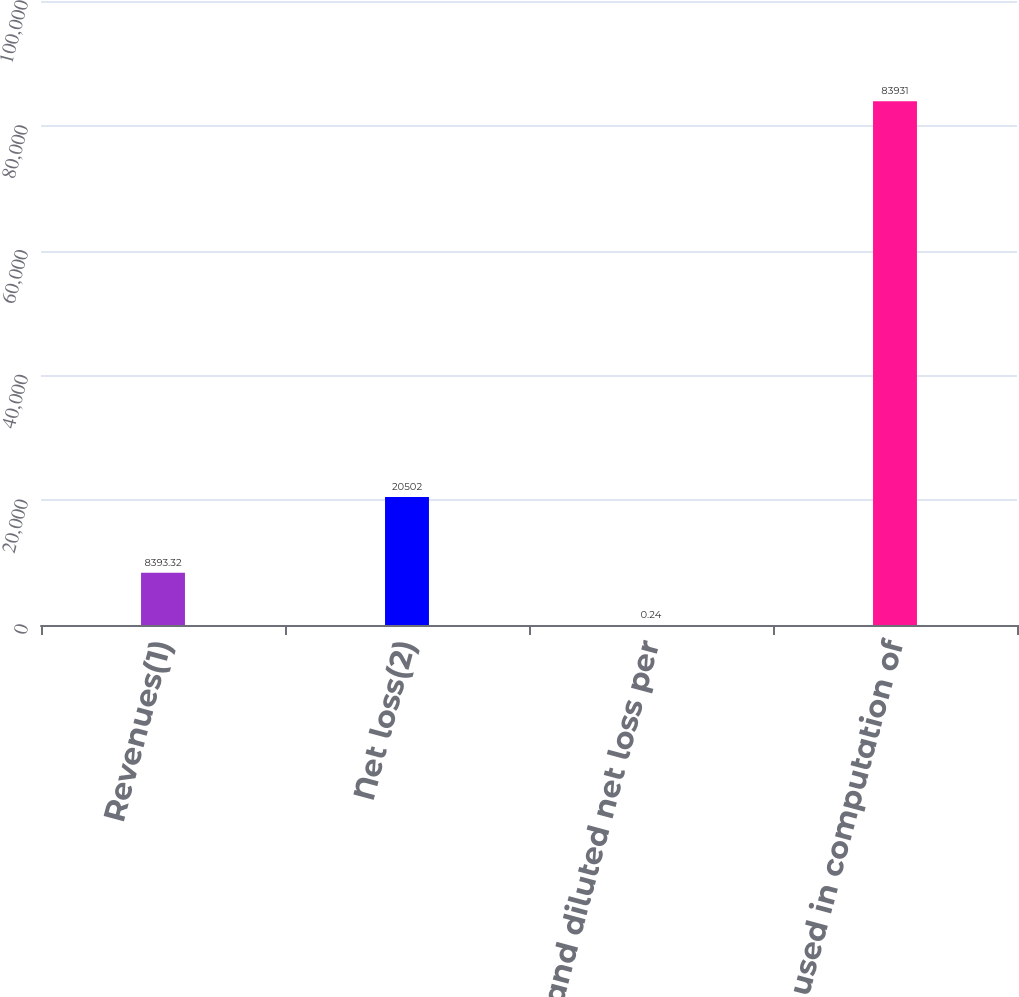Convert chart. <chart><loc_0><loc_0><loc_500><loc_500><bar_chart><fcel>Revenues(1)<fcel>Net loss(2)<fcel>Basic and diluted net loss per<fcel>Shares used in computation of<nl><fcel>8393.32<fcel>20502<fcel>0.24<fcel>83931<nl></chart> 